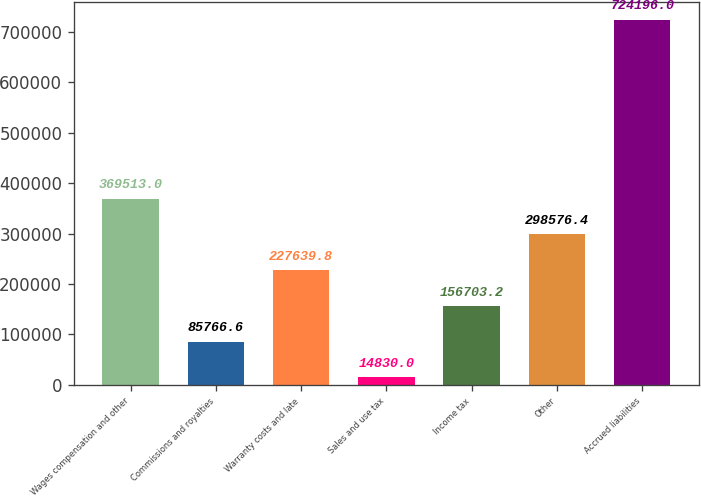Convert chart. <chart><loc_0><loc_0><loc_500><loc_500><bar_chart><fcel>Wages compensation and other<fcel>Commissions and royalties<fcel>Warranty costs and late<fcel>Sales and use tax<fcel>Income tax<fcel>Other<fcel>Accrued liabilities<nl><fcel>369513<fcel>85766.6<fcel>227640<fcel>14830<fcel>156703<fcel>298576<fcel>724196<nl></chart> 